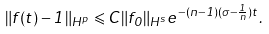<formula> <loc_0><loc_0><loc_500><loc_500>\| f ( t ) - 1 \| _ { H ^ { p } } \leqslant C \| f _ { 0 } \| _ { H ^ { s } } e ^ { - ( n - 1 ) ( \sigma - \frac { 1 } { n } ) t } .</formula> 